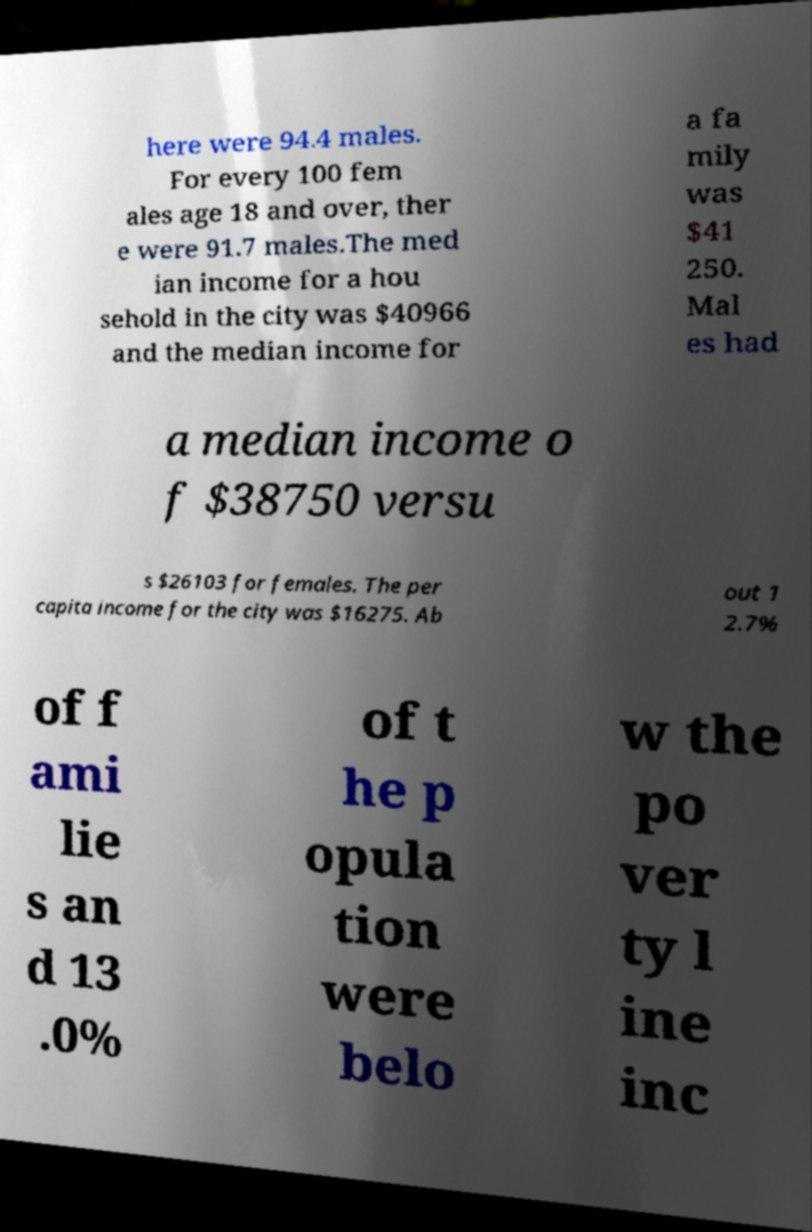Please read and relay the text visible in this image. What does it say? here were 94.4 males. For every 100 fem ales age 18 and over, ther e were 91.7 males.The med ian income for a hou sehold in the city was $40966 and the median income for a fa mily was $41 250. Mal es had a median income o f $38750 versu s $26103 for females. The per capita income for the city was $16275. Ab out 1 2.7% of f ami lie s an d 13 .0% of t he p opula tion were belo w the po ver ty l ine inc 